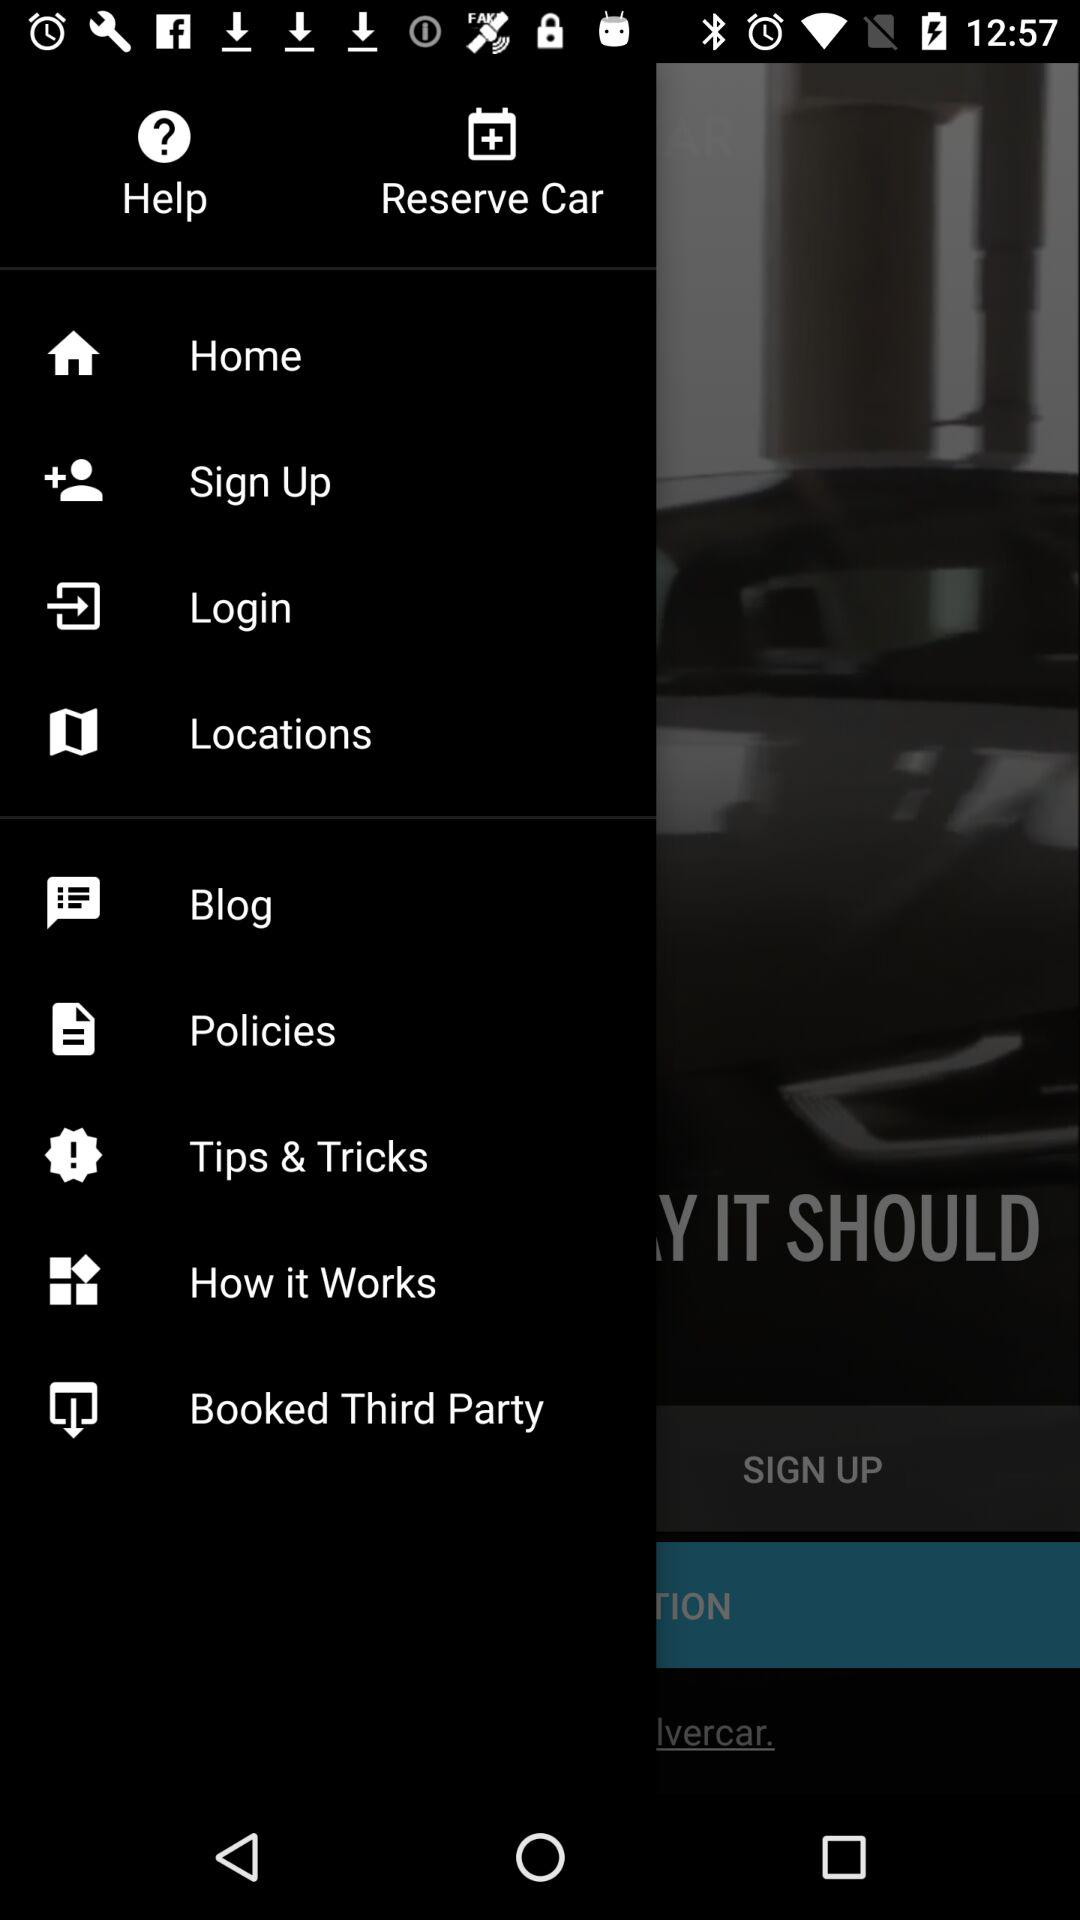What is the name of the application? The name of the application is "SILVERCAR". 